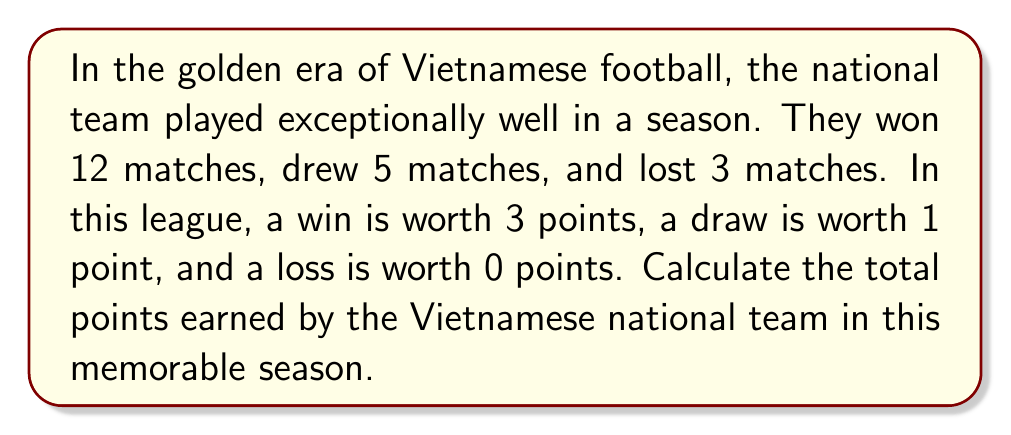Give your solution to this math problem. Let's break down the problem and solve it step by step:

1. Given information:
   - Wins: 12 matches
   - Draws: 5 matches
   - Losses: 3 matches
   - Points system: Win = 3 points, Draw = 1 point, Loss = 0 points

2. Calculate points from wins:
   $$ \text{Points from wins} = 12 \times 3 = 36 \text{ points} $$

3. Calculate points from draws:
   $$ \text{Points from draws} = 5 \times 1 = 5 \text{ points} $$

4. Calculate points from losses:
   $$ \text{Points from losses} = 3 \times 0 = 0 \text{ points} $$

5. Sum up the total points:
   $$ \text{Total points} = \text{Points from wins} + \text{Points from draws} + \text{Points from losses} $$
   $$ \text{Total points} = 36 + 5 + 0 = 41 \text{ points} $$

Therefore, the Vietnamese national team earned a total of 41 points in this memorable season.
Answer: 41 points 